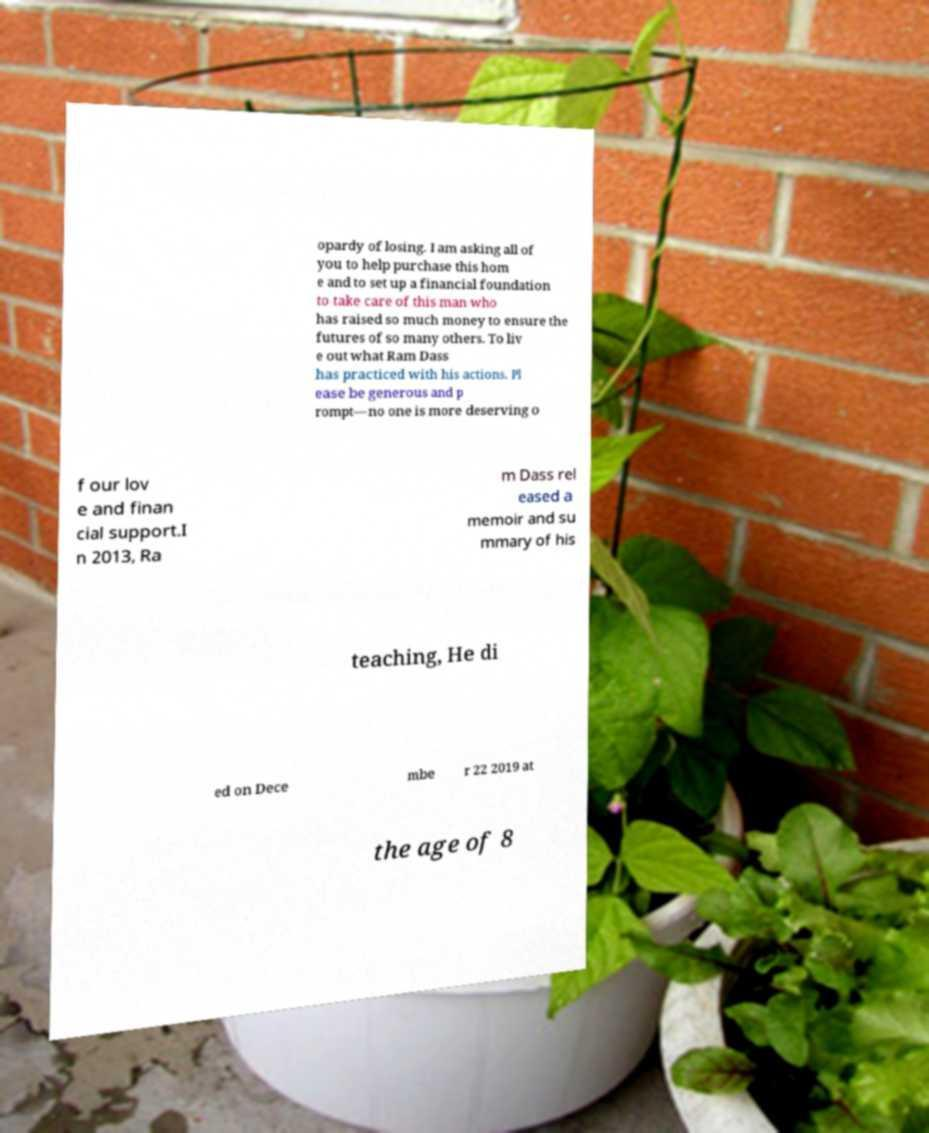Can you accurately transcribe the text from the provided image for me? opardy of losing. I am asking all of you to help purchase this hom e and to set up a financial foundation to take care of this man who has raised so much money to ensure the futures of so many others. To liv e out what Ram Dass has practiced with his actions. Pl ease be generous and p rompt—no one is more deserving o f our lov e and finan cial support.I n 2013, Ra m Dass rel eased a memoir and su mmary of his teaching, He di ed on Dece mbe r 22 2019 at the age of 8 